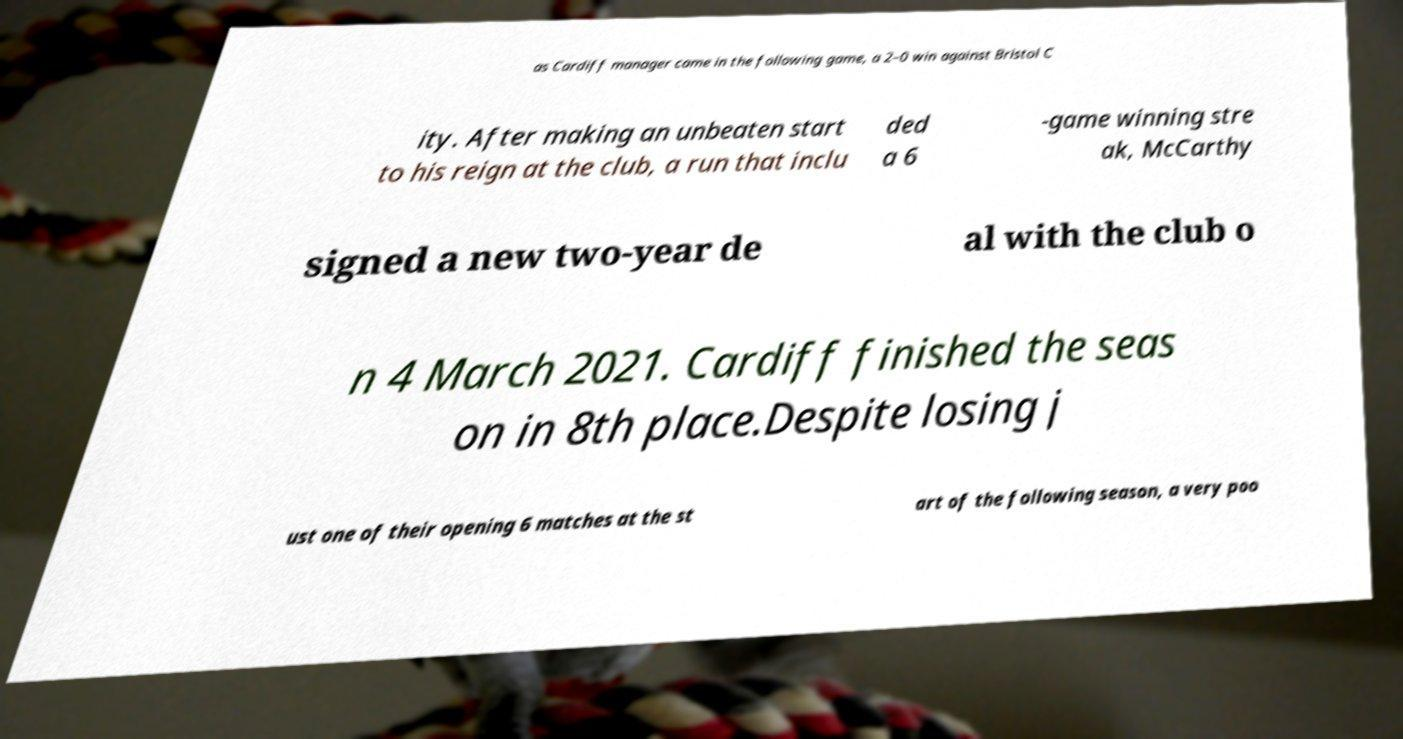Please identify and transcribe the text found in this image. as Cardiff manager came in the following game, a 2–0 win against Bristol C ity. After making an unbeaten start to his reign at the club, a run that inclu ded a 6 -game winning stre ak, McCarthy signed a new two-year de al with the club o n 4 March 2021. Cardiff finished the seas on in 8th place.Despite losing j ust one of their opening 6 matches at the st art of the following season, a very poo 